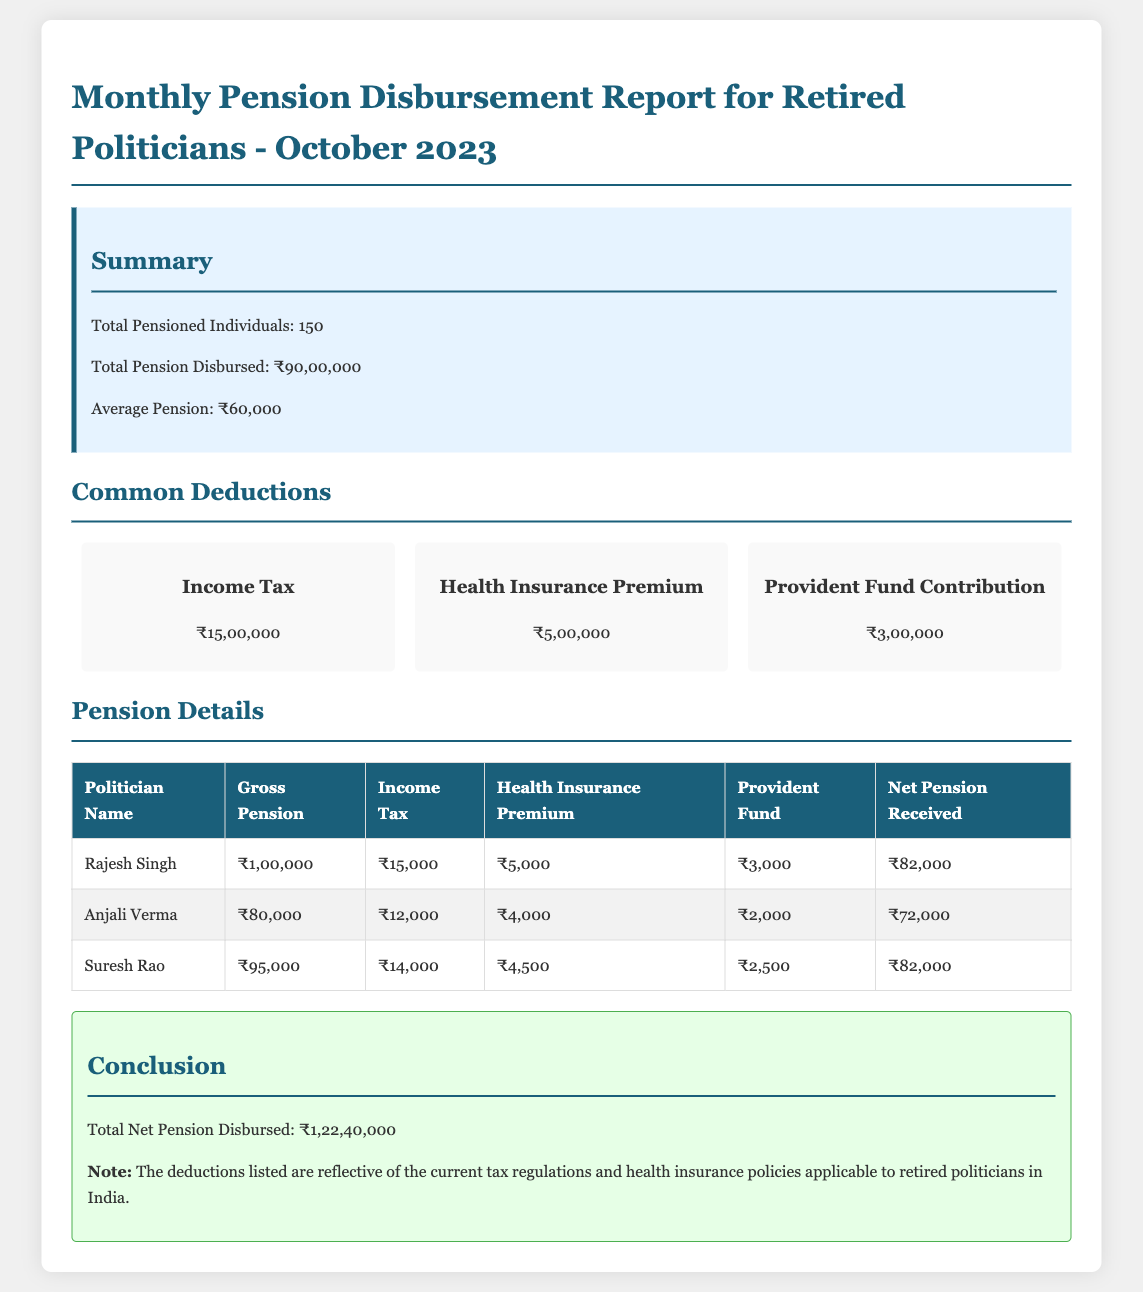What is the total pension disbursed? The total pension disbursed is stated in the summary section of the report as ₹90,00,000.
Answer: ₹90,00,000 What is the average pension amount? The average pension amount is mentioned in the summary section, calculated from the total amount divided by the number of pensioned individuals.
Answer: ₹60,000 How many pensioned individuals are listed? The number of pensioned individuals is provided in the summary section of the report as 150.
Answer: 150 What is the total income tax deduction? The total income tax deduction is detailed in the deductions section of the report and is ₹15,00,000.
Answer: ₹15,00,000 What is the net pension received by Anjali Verma? The net pension received by Anjali Verma is listed in the pension details table as ₹72,000.
Answer: ₹72,000 What is the total net pension disbursed? The total net pension disbursed is provided in the conclusion section of the report as ₹1,22,40,000.
Answer: ₹1,22,40,000 Which deduction is the highest? The highest deduction listed is income tax at ₹15,00,000.
Answer: Income Tax What is the gross pension amount for Suresh Rao? The gross pension amount for Suresh Rao is specified in the pension details table as ₹95,000.
Answer: ₹95,000 What is the health insurance premium deduction? The health insurance premium deduction is noted in the deductions section as ₹5,00,000.
Answer: ₹5,00,000 